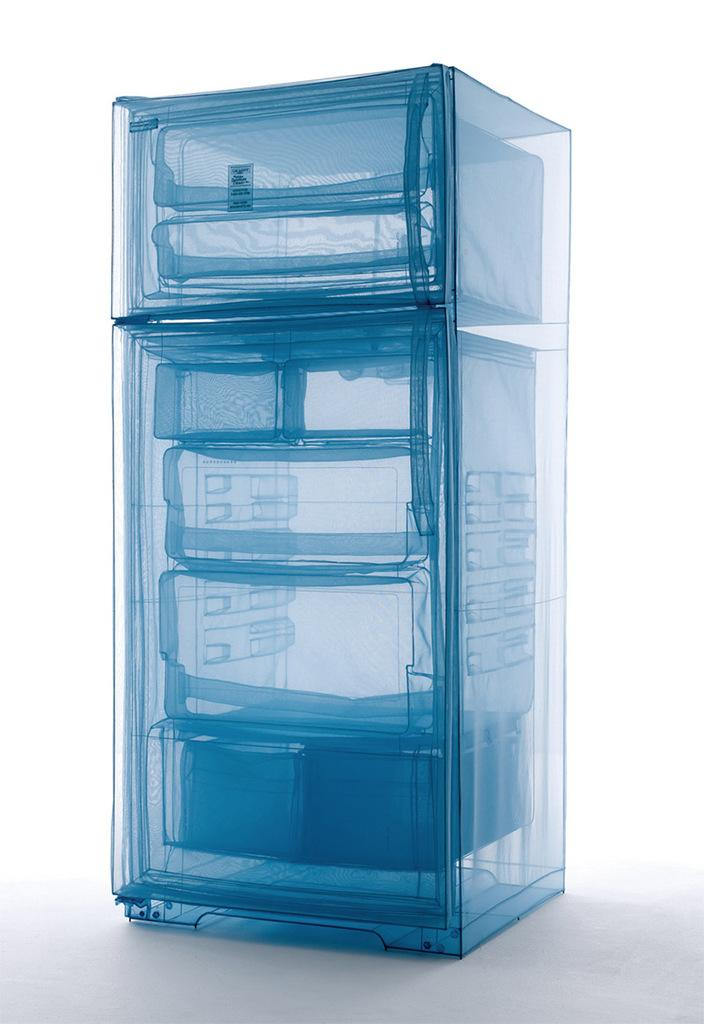What color is the background of the image? The background of the image is white. What appliance can be seen in the image? There is a refrigerator in the image. What type of theory is being discussed near the refrigerator in the image? There is no discussion or theory present in the image; it only features a refrigerator and a white background. 